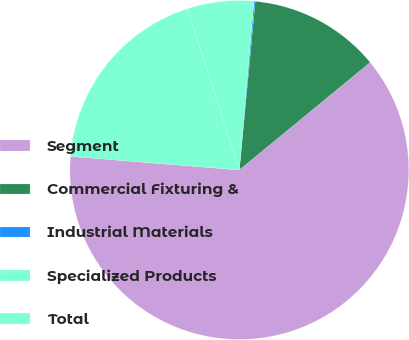Convert chart to OTSL. <chart><loc_0><loc_0><loc_500><loc_500><pie_chart><fcel>Segment<fcel>Commercial Fixturing &<fcel>Industrial Materials<fcel>Specialized Products<fcel>Total<nl><fcel>62.24%<fcel>12.55%<fcel>0.12%<fcel>6.34%<fcel>18.76%<nl></chart> 